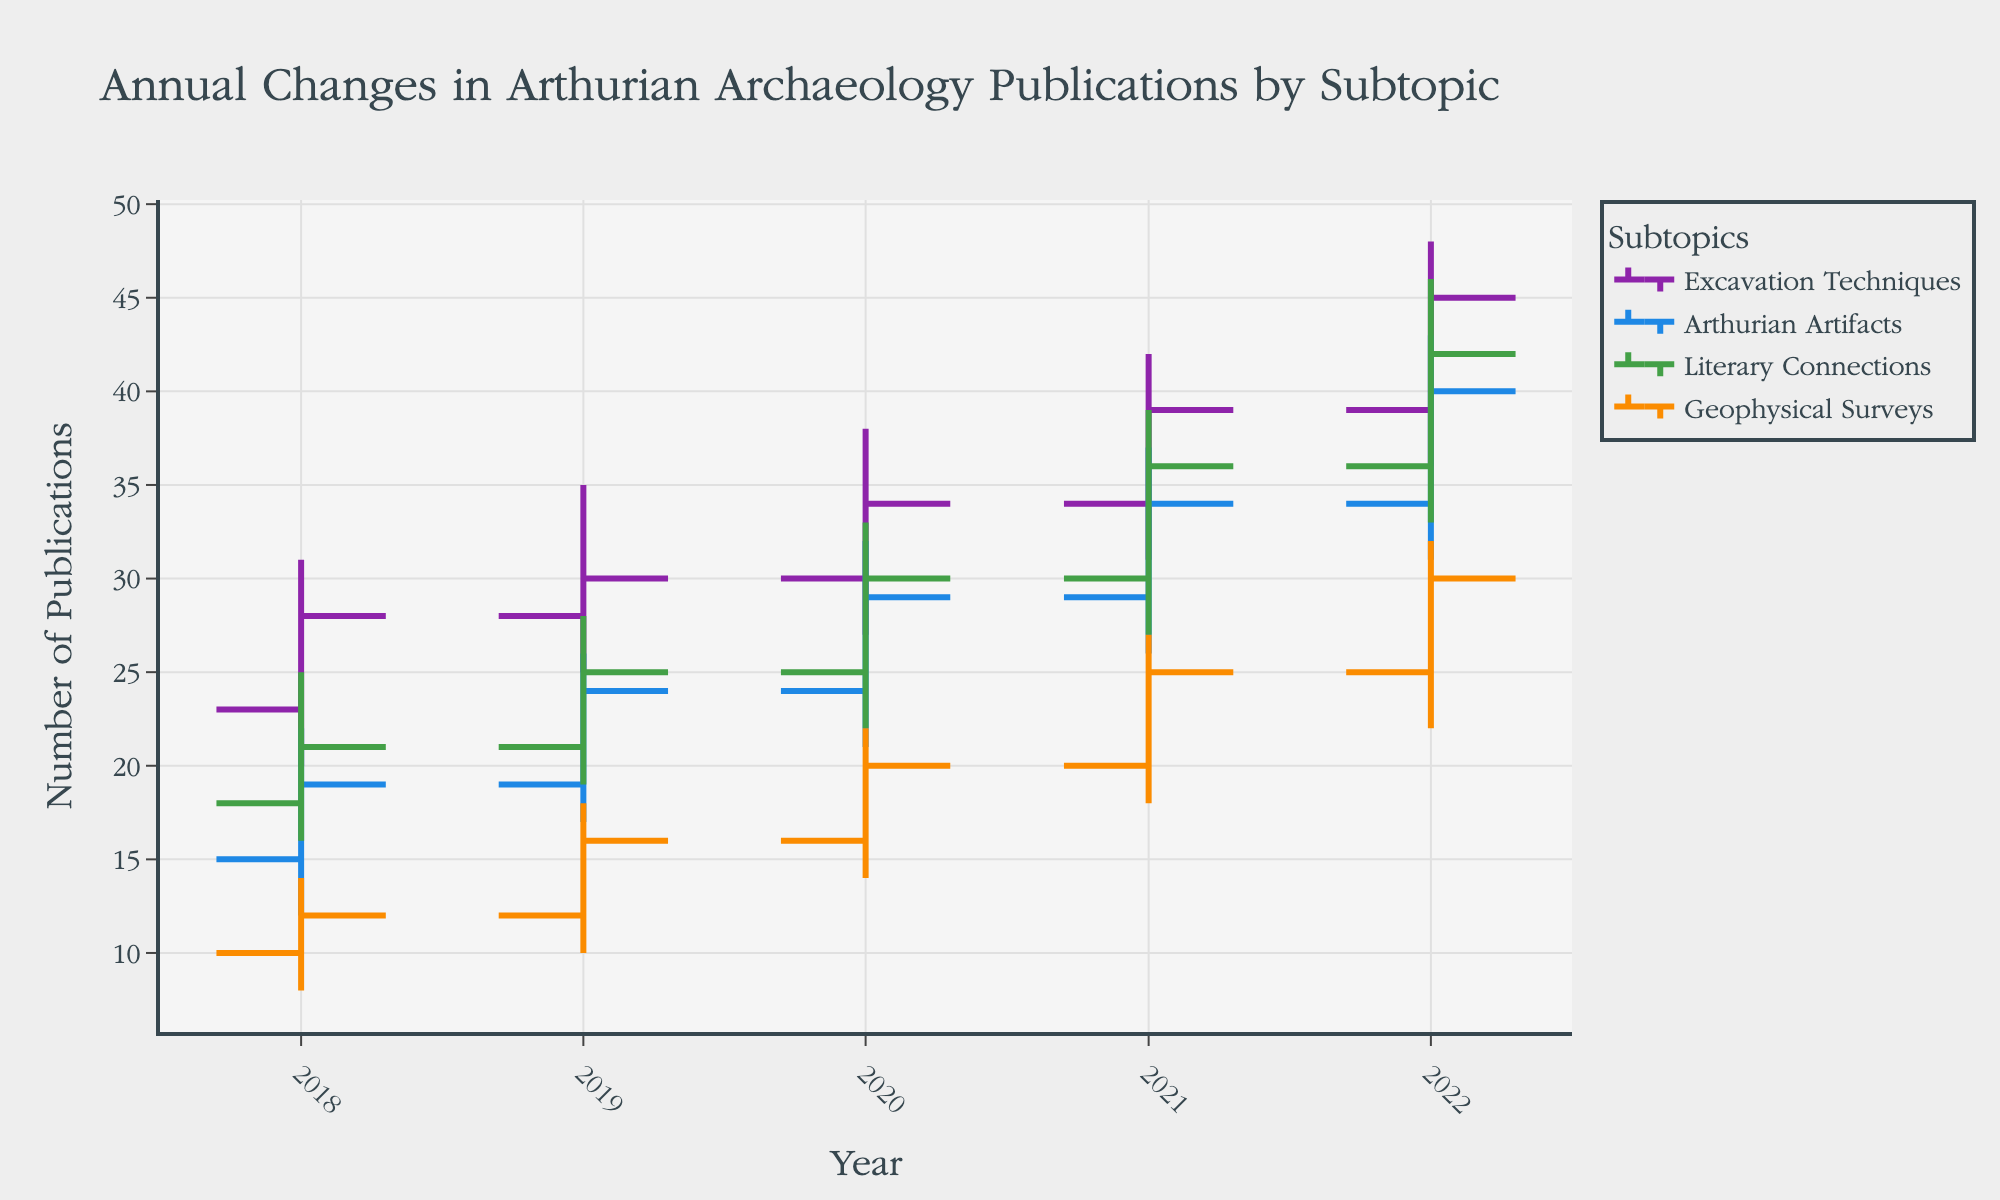What is the title of the figure? The title can be found prominently displayed at the top of the figure. It is often formatted in a larger and bolder font.
Answer: Annual Changes in Arthurian Archaeology Publications by Subtopic What is the number of publications for "Arthurian Artifacts" in 2022? The "Close" value for the year 2022 under the "Arthurian Artifacts" subtopic shows the number of publications at the end of the year.
Answer: 40 Which subtopic had the highest peak number of publications at any point between 2018 and 2022? By observing the "High" values for all subtopics over the entire period, you can identify the peak publication number. "Excavation Techniques" had the highest peak with 48 publications in 2022.
Answer: Excavation Techniques What is the range (difference between the highest and lowest number) of publications for "Geophysical Surveys" in 2021? The range is calculated by subtracting the "Low" value from the "High" value for "Geophysical Surveys" in 2021: 27 - 18 = 9.
Answer: 9 How did the number of publications for "Literary Connections" change from 2020 to 2021? To determine the change, subtract the 2020 "Close" value from the 2021 "Close" value for "Literary Connections": 36 - 30 = 6 publications.
Answer: Increased by 6 In which year did "Excavation Techniques" experience the greatest increase in the number of publications from the previous year's closure? Calculate the annual changes by subtracting the previous year's "Close" value from the current year's "Close" value for "Excavation Techniques". The greatest increase occurred from 2021 to 2022: 45 - 39 = 6 publications.
Answer: 2022 Which subtopic showed the most significant drop in publications from its annual peak in any given year? Compare the difference between the "High" and "Close" values for all subtopics in each year to find the largest drop. "Arthurian Artifacts" in 2021 dropped the most, from 37 to 34 publications, a drop of 3 publications.
Answer: Arthurian Artifacts in 2021 Between 2019 and 2022, was there ever a year when "Geophysical Surveys" publications did not increase over the previous year's closing number? By comparing the year-to-year "Close" values for "Geophysical Surveys" from 2019 to 2022, we find no year where publications didn't increase over the previous year's closing number.
Answer: No What are the total 'Open' and 'Close' values for "Literary Connections" from 2018 to 2021? Sum the "Open" and "Close" values for all years from 2018 to 2021 for "Literary Connections": Open (18+21+25+30) = 94, Close (21+25+30+36) = 112.
Answer: Open: 94, Close: 112 What is the average closing publication number for "Arthurian Artifacts" from 2018 to 2022? Sum the "Close" values from 2018 to 2022 for "Arthurian Artifacts" and divide by the number of years (5): (19+24+29+34+40)/5 = 29.2.
Answer: 29.2 